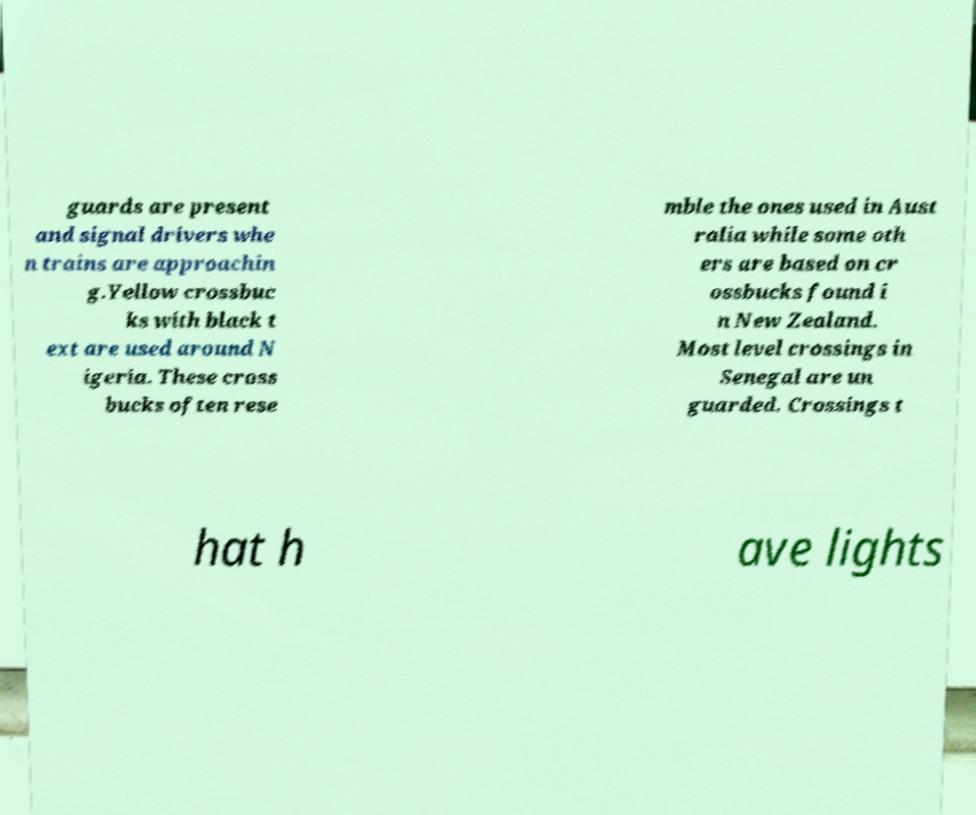Can you read and provide the text displayed in the image?This photo seems to have some interesting text. Can you extract and type it out for me? guards are present and signal drivers whe n trains are approachin g.Yellow crossbuc ks with black t ext are used around N igeria. These cross bucks often rese mble the ones used in Aust ralia while some oth ers are based on cr ossbucks found i n New Zealand. Most level crossings in Senegal are un guarded. Crossings t hat h ave lights 